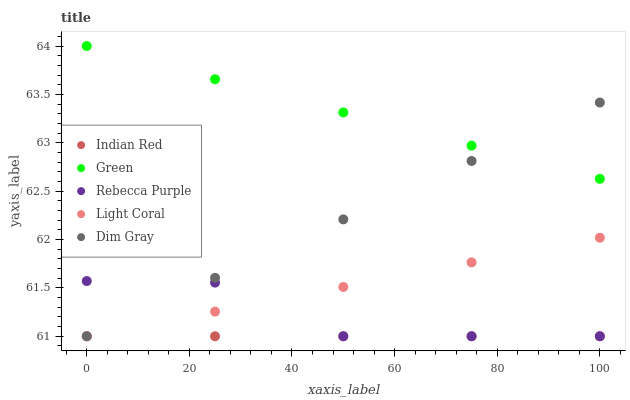Does Indian Red have the minimum area under the curve?
Answer yes or no. Yes. Does Green have the maximum area under the curve?
Answer yes or no. Yes. Does Dim Gray have the minimum area under the curve?
Answer yes or no. No. Does Dim Gray have the maximum area under the curve?
Answer yes or no. No. Is Green the smoothest?
Answer yes or no. Yes. Is Rebecca Purple the roughest?
Answer yes or no. Yes. Is Dim Gray the smoothest?
Answer yes or no. No. Is Dim Gray the roughest?
Answer yes or no. No. Does Light Coral have the lowest value?
Answer yes or no. Yes. Does Green have the lowest value?
Answer yes or no. No. Does Green have the highest value?
Answer yes or no. Yes. Does Dim Gray have the highest value?
Answer yes or no. No. Is Rebecca Purple less than Green?
Answer yes or no. Yes. Is Green greater than Indian Red?
Answer yes or no. Yes. Does Light Coral intersect Rebecca Purple?
Answer yes or no. Yes. Is Light Coral less than Rebecca Purple?
Answer yes or no. No. Is Light Coral greater than Rebecca Purple?
Answer yes or no. No. Does Rebecca Purple intersect Green?
Answer yes or no. No. 